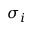<formula> <loc_0><loc_0><loc_500><loc_500>\sigma _ { i }</formula> 